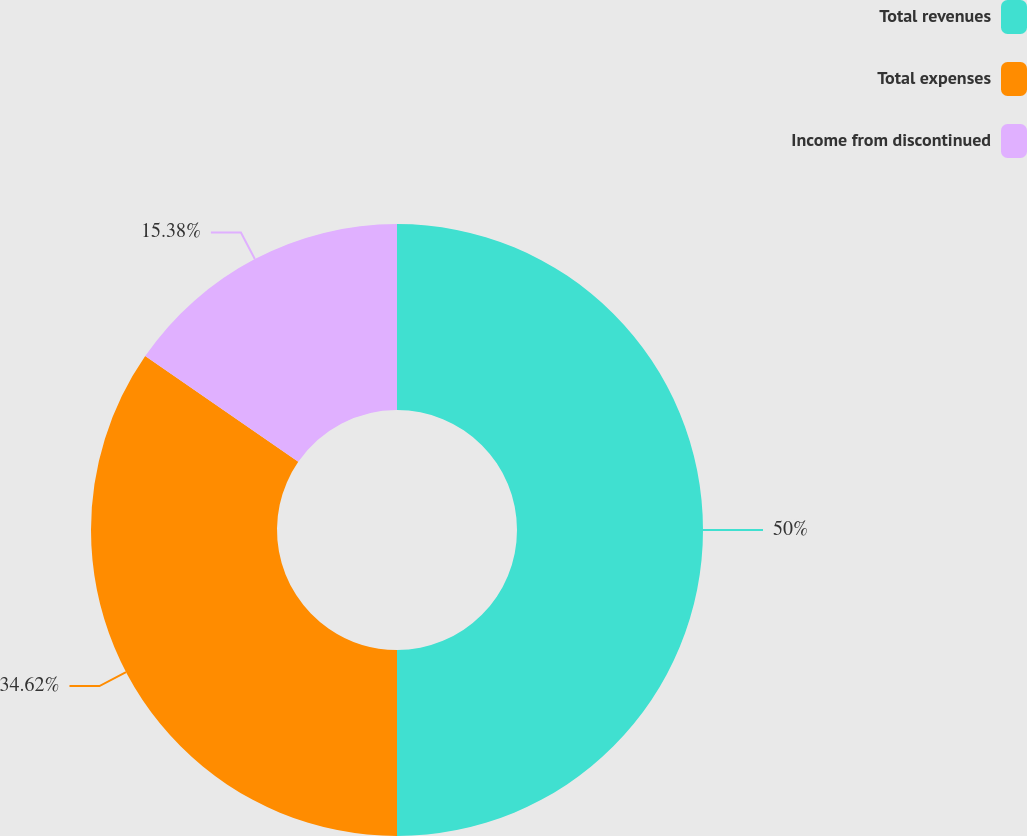Convert chart to OTSL. <chart><loc_0><loc_0><loc_500><loc_500><pie_chart><fcel>Total revenues<fcel>Total expenses<fcel>Income from discontinued<nl><fcel>50.0%<fcel>34.62%<fcel>15.38%<nl></chart> 